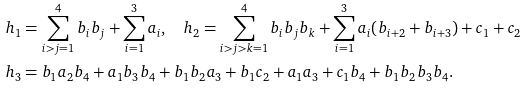<formula> <loc_0><loc_0><loc_500><loc_500>& h _ { 1 } = \sum _ { i > j = 1 } ^ { 4 } b _ { i } b _ { j } + \sum _ { i = 1 } ^ { 3 } a _ { i } , \quad h _ { 2 } = \sum _ { i > j > k = 1 } ^ { 4 } { b _ { i } b _ { j } b _ { k } } + \sum _ { i = 1 } ^ { 3 } a _ { i } ( b _ { i + 2 } + b _ { i + 3 } ) + c _ { 1 } + c _ { 2 } \\ & h _ { 3 } = b _ { 1 } a _ { 2 } b _ { 4 } + a _ { 1 } b _ { 3 } b _ { 4 } + b _ { 1 } b _ { 2 } a _ { 3 } + b _ { 1 } c _ { 2 } + a _ { 1 } a _ { 3 } + c _ { 1 } b _ { 4 } + b _ { 1 } b _ { 2 } b _ { 3 } b _ { 4 } .</formula> 